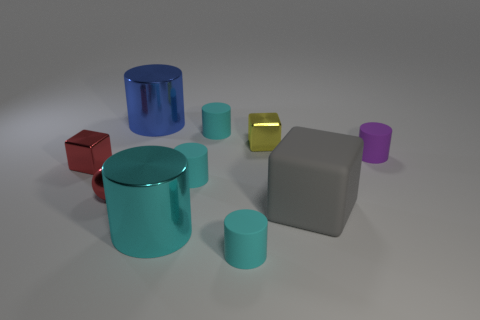What material is the cube that is both behind the big gray matte block and to the right of the blue cylinder?
Your response must be concise. Metal. What shape is the small thing that is left of the small sphere?
Your answer should be compact. Cube. There is a large object that is behind the small cyan object that is behind the red block; what shape is it?
Keep it short and to the point. Cylinder. Is there another matte thing that has the same shape as the big gray object?
Keep it short and to the point. No. There is a blue metal object that is the same size as the rubber block; what is its shape?
Provide a succinct answer. Cylinder. Are there any large objects that are in front of the cyan cylinder in front of the large shiny cylinder in front of the big rubber block?
Offer a terse response. No. Are there any blue rubber cylinders that have the same size as the yellow metal thing?
Give a very brief answer. No. There is a red thing that is to the right of the red cube; what size is it?
Your response must be concise. Small. What is the color of the tiny cube right of the tiny red shiny object that is on the right side of the tiny red cube behind the shiny ball?
Provide a succinct answer. Yellow. What is the color of the cylinder right of the tiny cyan cylinder in front of the big cyan cylinder?
Offer a very short reply. Purple. 